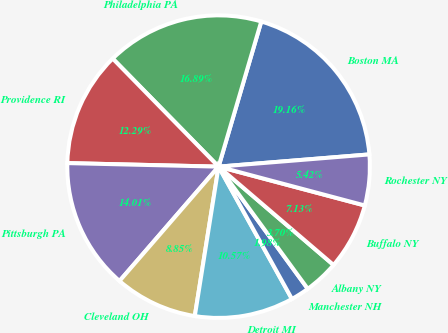Convert chart to OTSL. <chart><loc_0><loc_0><loc_500><loc_500><pie_chart><fcel>Boston MA<fcel>Philadelphia PA<fcel>Providence RI<fcel>Pittsburgh PA<fcel>Cleveland OH<fcel>Detroit MI<fcel>Manchester NH<fcel>Albany NY<fcel>Buffalo NY<fcel>Rochester NY<nl><fcel>19.16%<fcel>16.89%<fcel>12.29%<fcel>14.01%<fcel>8.85%<fcel>10.57%<fcel>1.98%<fcel>3.7%<fcel>7.13%<fcel>5.42%<nl></chart> 